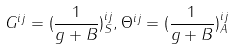<formula> <loc_0><loc_0><loc_500><loc_500>G ^ { i j } = ( \frac { 1 } { g + B } ) _ { S } ^ { i j } , \Theta ^ { i j } = ( \frac { 1 } { g + B } ) _ { A } ^ { i j }</formula> 